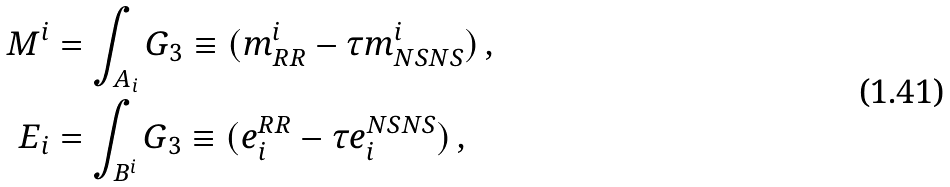Convert formula to latex. <formula><loc_0><loc_0><loc_500><loc_500>M ^ { i } & = \int _ { A _ { i } } G _ { 3 } \equiv ( m _ { R R } ^ { i } - \tau m _ { N S N S } ^ { i } ) \, , \\ E _ { i } & = \int _ { B ^ { i } } G _ { 3 } \equiv ( e ^ { R R } _ { i } - \tau e ^ { N S N S } _ { i } ) \, ,</formula> 